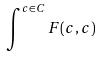Convert formula to latex. <formula><loc_0><loc_0><loc_500><loc_500>\int ^ { c \in C } F ( c , c )</formula> 